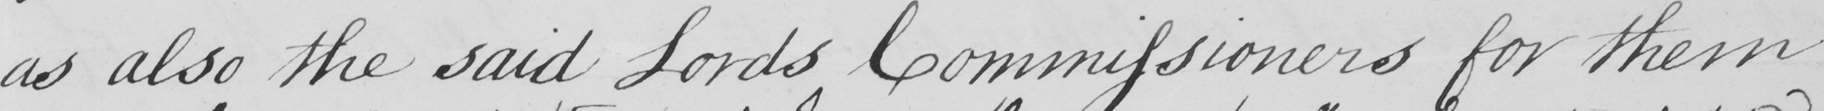What does this handwritten line say? as also the said Lords Commissioners for them- 